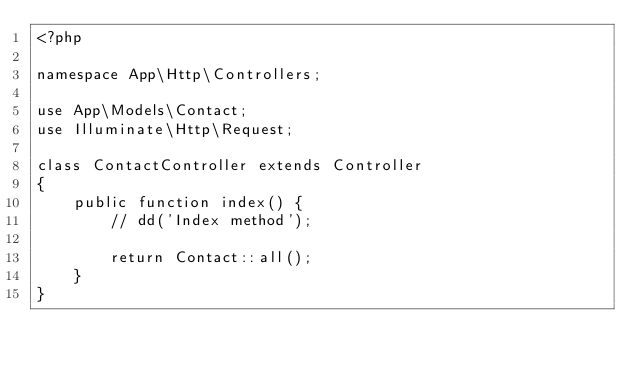Convert code to text. <code><loc_0><loc_0><loc_500><loc_500><_PHP_><?php

namespace App\Http\Controllers;

use App\Models\Contact;
use Illuminate\Http\Request;

class ContactController extends Controller
{
    public function index() {
        // dd('Index method');

        return Contact::all();
    }
}
</code> 